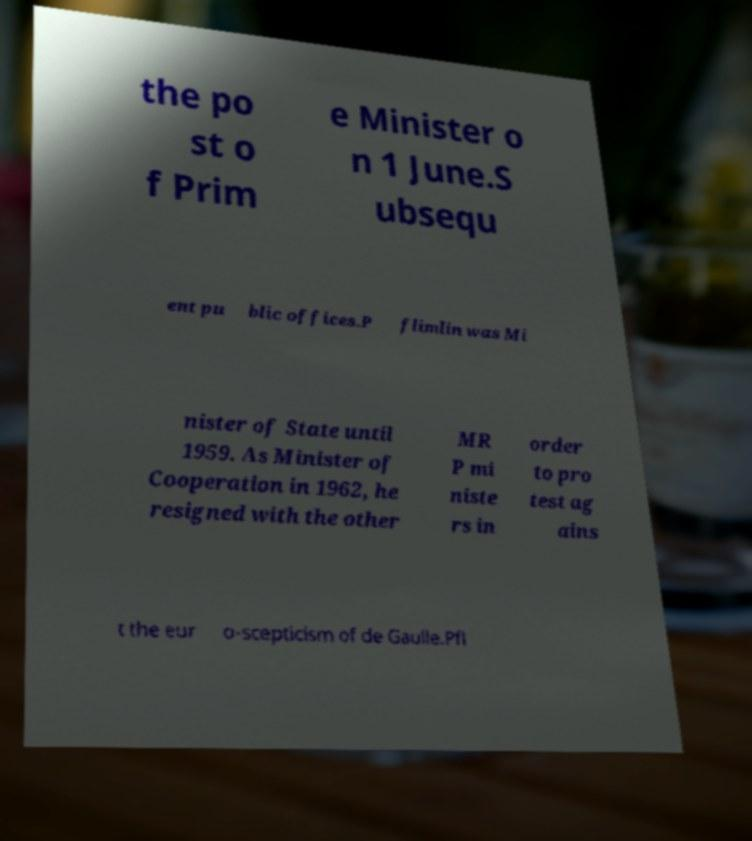There's text embedded in this image that I need extracted. Can you transcribe it verbatim? the po st o f Prim e Minister o n 1 June.S ubsequ ent pu blic offices.P flimlin was Mi nister of State until 1959. As Minister of Cooperation in 1962, he resigned with the other MR P mi niste rs in order to pro test ag ains t the eur o-scepticism of de Gaulle.Pfl 